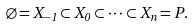<formula> <loc_0><loc_0><loc_500><loc_500>\varnothing = X _ { - 1 } \subset X _ { 0 } \subset \cdots \subset X _ { n } = P .</formula> 